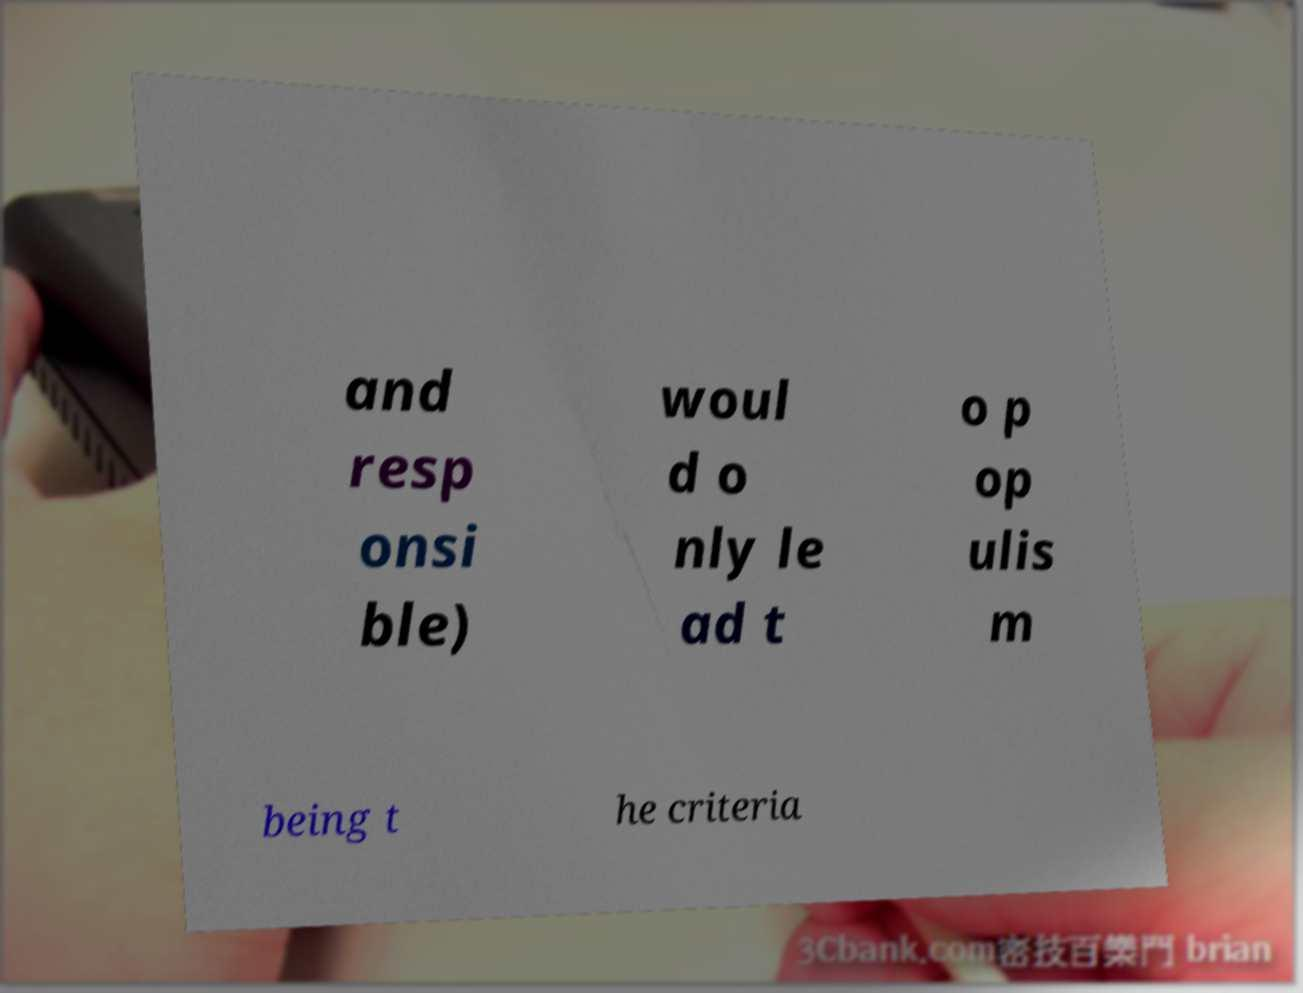There's text embedded in this image that I need extracted. Can you transcribe it verbatim? and resp onsi ble) woul d o nly le ad t o p op ulis m being t he criteria 